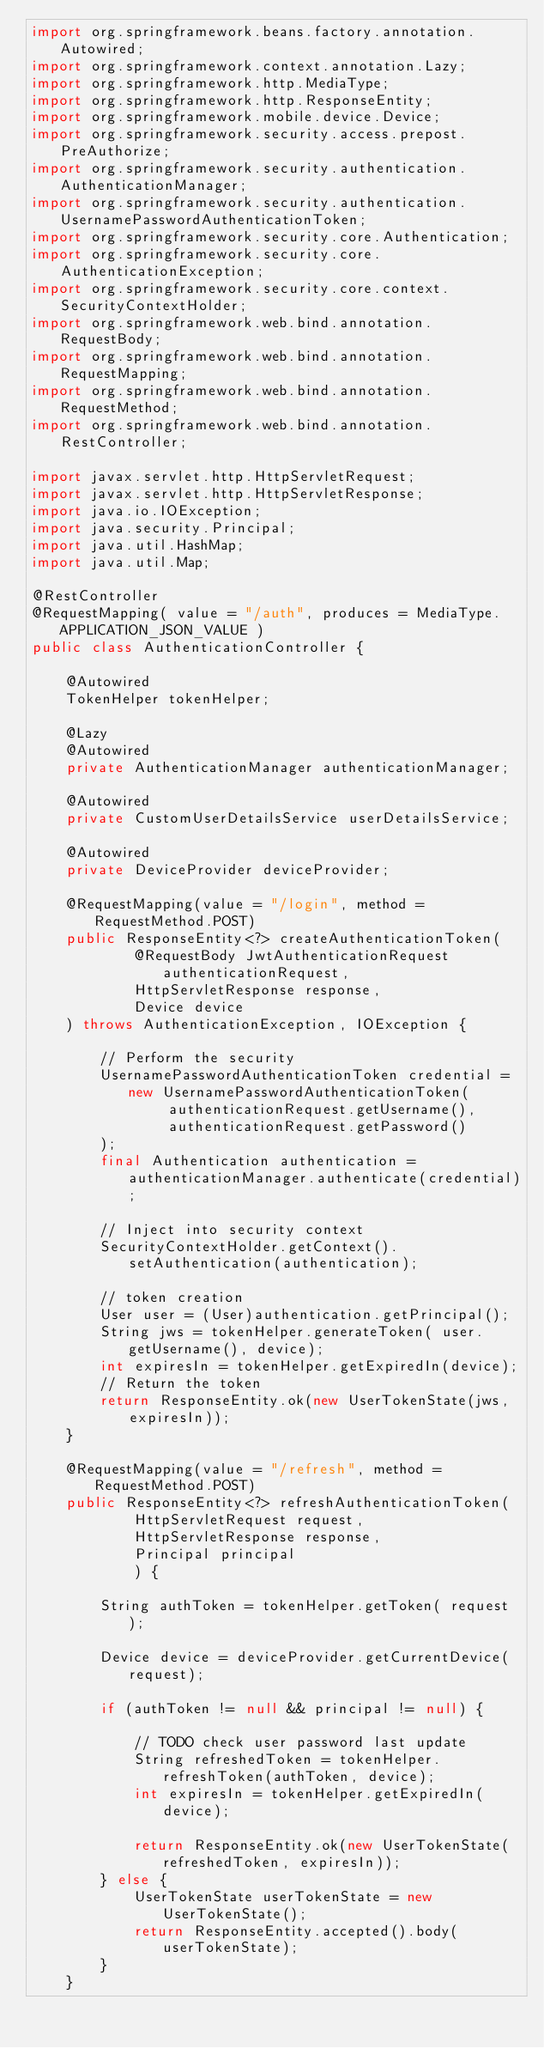<code> <loc_0><loc_0><loc_500><loc_500><_Java_>import org.springframework.beans.factory.annotation.Autowired;
import org.springframework.context.annotation.Lazy;
import org.springframework.http.MediaType;
import org.springframework.http.ResponseEntity;
import org.springframework.mobile.device.Device;
import org.springframework.security.access.prepost.PreAuthorize;
import org.springframework.security.authentication.AuthenticationManager;
import org.springframework.security.authentication.UsernamePasswordAuthenticationToken;
import org.springframework.security.core.Authentication;
import org.springframework.security.core.AuthenticationException;
import org.springframework.security.core.context.SecurityContextHolder;
import org.springframework.web.bind.annotation.RequestBody;
import org.springframework.web.bind.annotation.RequestMapping;
import org.springframework.web.bind.annotation.RequestMethod;
import org.springframework.web.bind.annotation.RestController;

import javax.servlet.http.HttpServletRequest;
import javax.servlet.http.HttpServletResponse;
import java.io.IOException;
import java.security.Principal;
import java.util.HashMap;
import java.util.Map;

@RestController
@RequestMapping( value = "/auth", produces = MediaType.APPLICATION_JSON_VALUE )
public class AuthenticationController {

    @Autowired
    TokenHelper tokenHelper;

    @Lazy
    @Autowired
    private AuthenticationManager authenticationManager;

    @Autowired
    private CustomUserDetailsService userDetailsService;

    @Autowired
    private DeviceProvider deviceProvider;

    @RequestMapping(value = "/login", method = RequestMethod.POST)
    public ResponseEntity<?> createAuthenticationToken(
            @RequestBody JwtAuthenticationRequest authenticationRequest,
            HttpServletResponse response,
            Device device
    ) throws AuthenticationException, IOException {

        // Perform the security
        UsernamePasswordAuthenticationToken credential = new UsernamePasswordAuthenticationToken(
                authenticationRequest.getUsername(),
                authenticationRequest.getPassword()
        );
        final Authentication authentication = authenticationManager.authenticate(credential);

        // Inject into security context
        SecurityContextHolder.getContext().setAuthentication(authentication);

        // token creation
        User user = (User)authentication.getPrincipal();
        String jws = tokenHelper.generateToken( user.getUsername(), device);
        int expiresIn = tokenHelper.getExpiredIn(device);
        // Return the token
        return ResponseEntity.ok(new UserTokenState(jws, expiresIn));
    }

    @RequestMapping(value = "/refresh", method = RequestMethod.POST)
    public ResponseEntity<?> refreshAuthenticationToken(
            HttpServletRequest request,
            HttpServletResponse response,
            Principal principal
            ) {

        String authToken = tokenHelper.getToken( request );

        Device device = deviceProvider.getCurrentDevice(request);

        if (authToken != null && principal != null) {

            // TODO check user password last update
            String refreshedToken = tokenHelper.refreshToken(authToken, device);
            int expiresIn = tokenHelper.getExpiredIn(device);

            return ResponseEntity.ok(new UserTokenState(refreshedToken, expiresIn));
        } else {
            UserTokenState userTokenState = new UserTokenState();
            return ResponseEntity.accepted().body(userTokenState);
        }
    }
</code> 